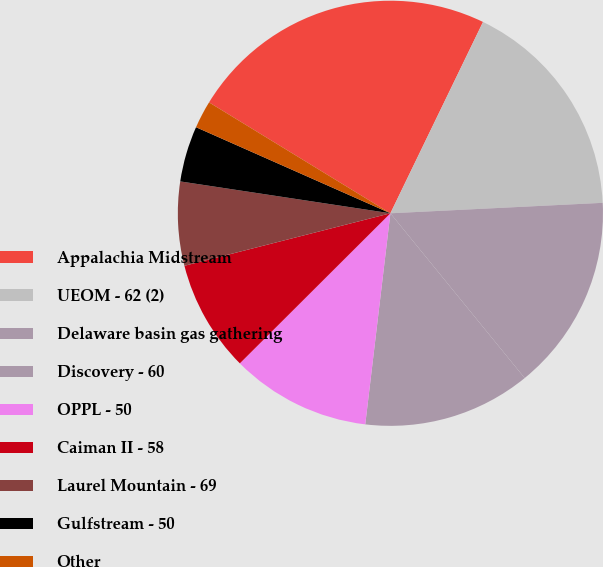Convert chart to OTSL. <chart><loc_0><loc_0><loc_500><loc_500><pie_chart><fcel>Appalachia Midstream<fcel>UEOM - 62 (2)<fcel>Delaware basin gas gathering<fcel>Discovery - 60<fcel>OPPL - 50<fcel>Caiman II - 58<fcel>Laurel Mountain - 69<fcel>Gulfstream - 50<fcel>Other<nl><fcel>23.44%<fcel>17.04%<fcel>14.9%<fcel>12.77%<fcel>10.64%<fcel>8.5%<fcel>6.37%<fcel>4.24%<fcel>2.1%<nl></chart> 